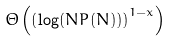Convert formula to latex. <formula><loc_0><loc_0><loc_500><loc_500>\Theta \left ( \left ( \log ( N P ( N ) ) \right ) ^ { 1 - x } \right )</formula> 